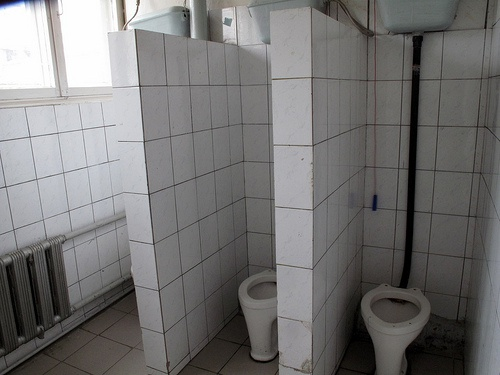Describe the objects in this image and their specific colors. I can see toilet in black and gray tones and toilet in black and gray tones in this image. 